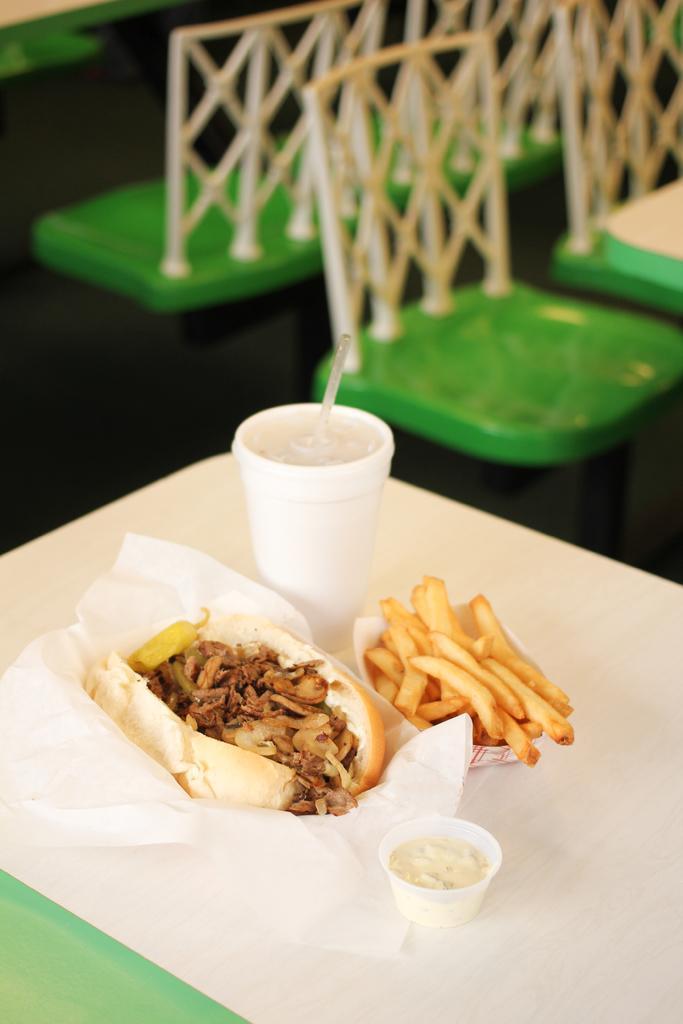Can you describe this image briefly? This is a zoomed in picture. In the center there is a table on the top of which a glass of drink, bowl containing some food, french fries and some food items are placed. In the background we can see the green color chairs placed on the ground. 